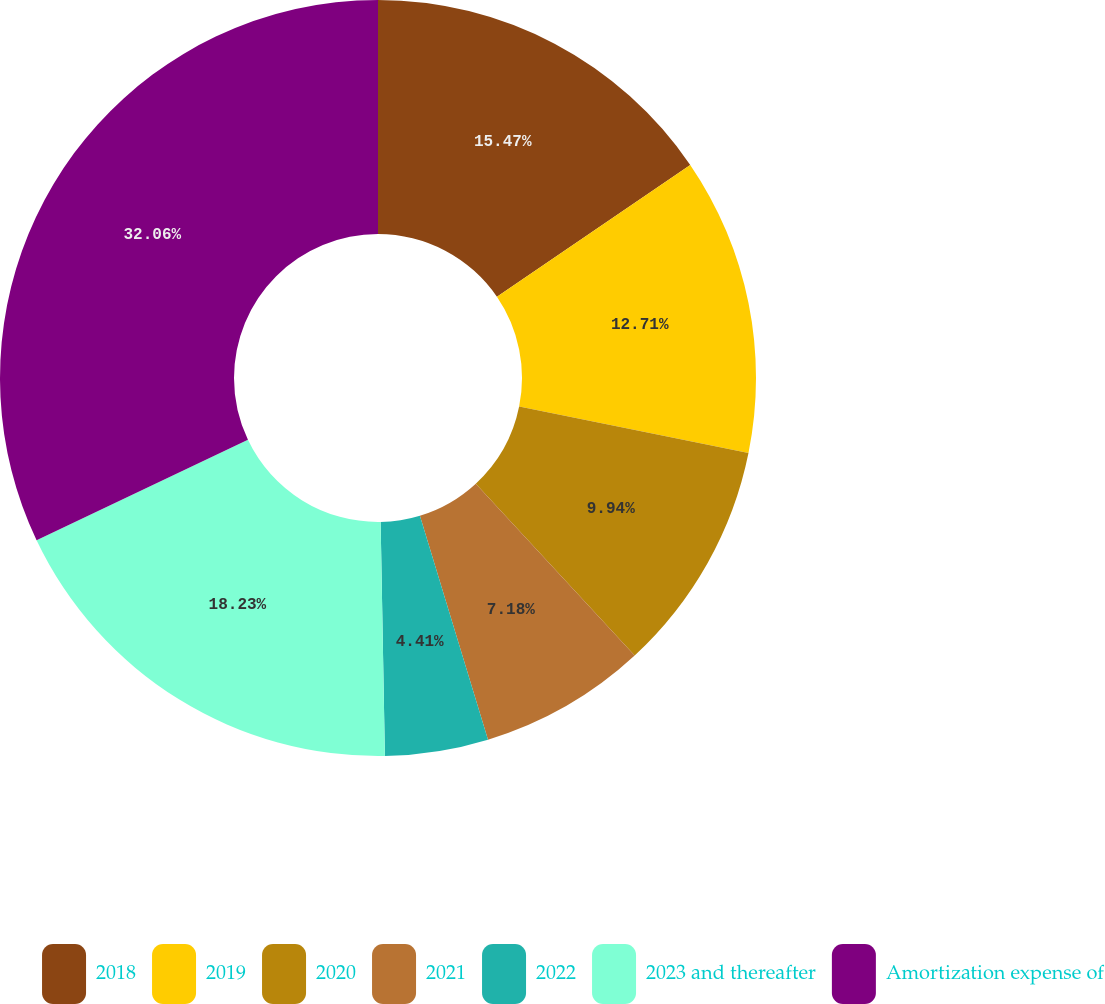<chart> <loc_0><loc_0><loc_500><loc_500><pie_chart><fcel>2018<fcel>2019<fcel>2020<fcel>2021<fcel>2022<fcel>2023 and thereafter<fcel>Amortization expense of<nl><fcel>15.47%<fcel>12.71%<fcel>9.94%<fcel>7.18%<fcel>4.41%<fcel>18.23%<fcel>32.06%<nl></chart> 